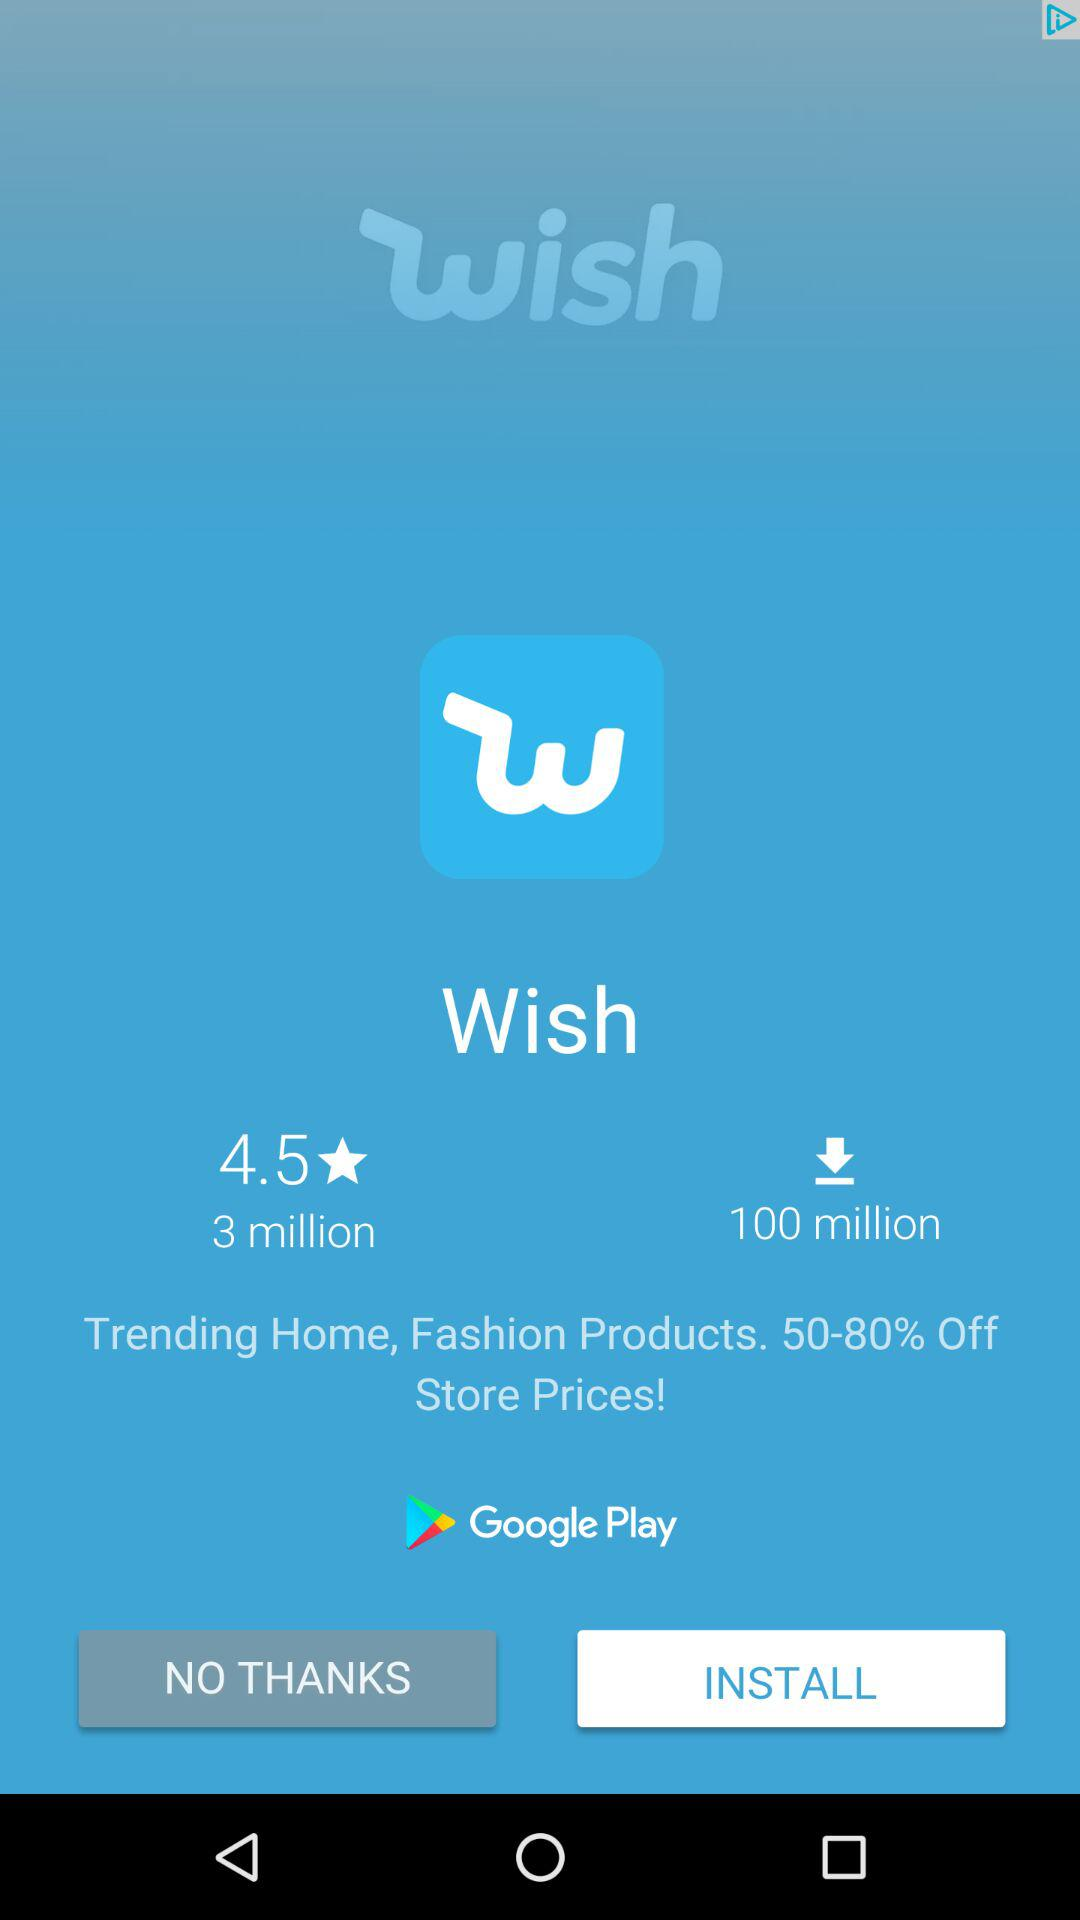How many more downloads does the app have than reviews?
Answer the question using a single word or phrase. 97 million 